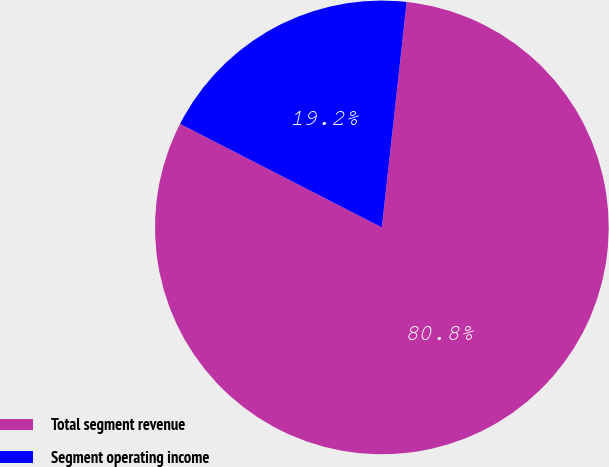<chart> <loc_0><loc_0><loc_500><loc_500><pie_chart><fcel>Total segment revenue<fcel>Segment operating income<nl><fcel>80.8%<fcel>19.2%<nl></chart> 